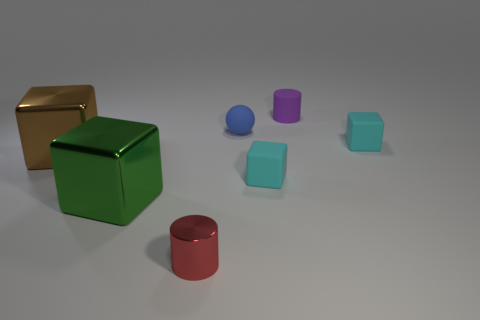Is the number of large green cubes that are to the left of the large green metallic object less than the number of small red metallic things that are on the right side of the small purple matte thing?
Give a very brief answer. No. Is there any other thing of the same color as the tiny rubber cylinder?
Ensure brevity in your answer.  No. There is a blue rubber thing; what shape is it?
Provide a succinct answer. Sphere. There is a tiny cylinder that is made of the same material as the tiny blue object; what color is it?
Your response must be concise. Purple. Is the number of large green objects greater than the number of green matte things?
Ensure brevity in your answer.  Yes. Is there a small shiny object?
Keep it short and to the point. Yes. What is the shape of the cyan object that is left of the cyan object that is right of the purple thing?
Keep it short and to the point. Cube. What number of objects are either tiny metallic things or tiny objects right of the small metallic cylinder?
Your answer should be compact. 5. What color is the small cylinder that is behind the cylinder that is to the left of the cylinder right of the tiny blue rubber ball?
Your response must be concise. Purple. There is a large brown thing that is the same shape as the green metallic thing; what is it made of?
Give a very brief answer. Metal. 